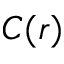<formula> <loc_0><loc_0><loc_500><loc_500>C ( r )</formula> 